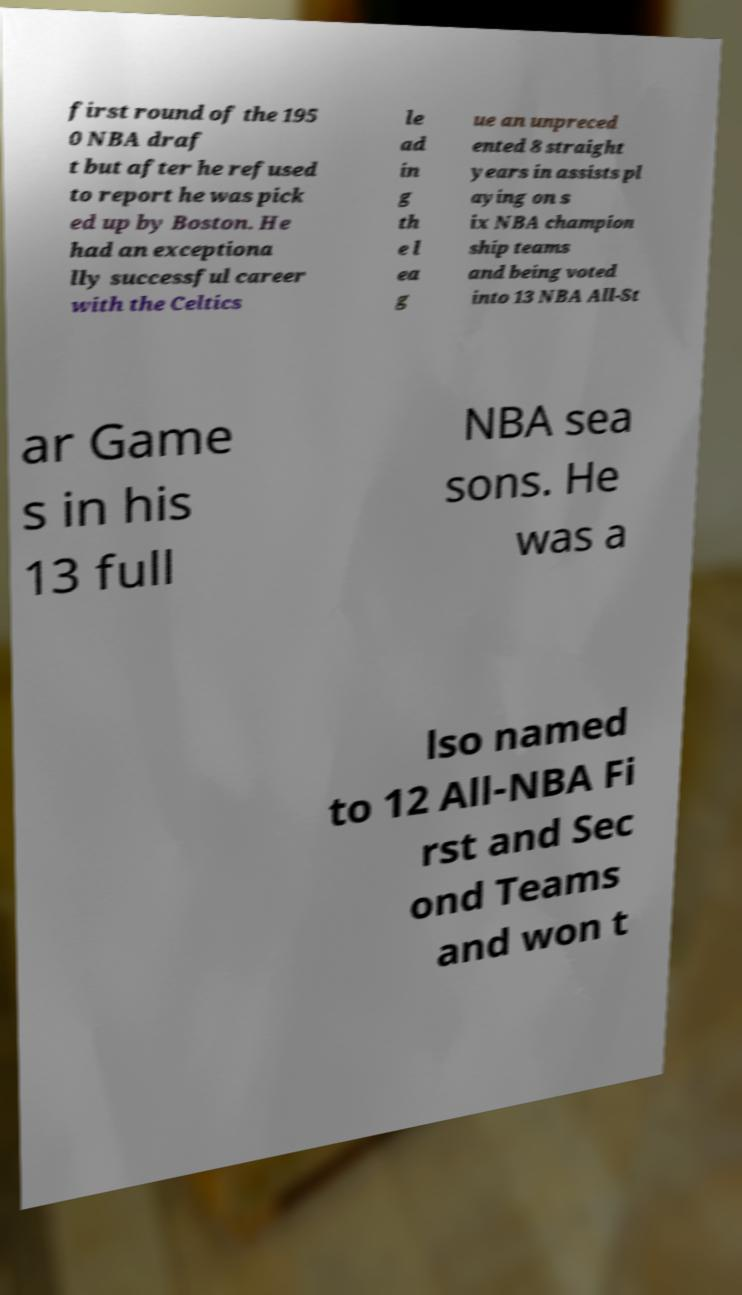Can you read and provide the text displayed in the image?This photo seems to have some interesting text. Can you extract and type it out for me? first round of the 195 0 NBA draf t but after he refused to report he was pick ed up by Boston. He had an exceptiona lly successful career with the Celtics le ad in g th e l ea g ue an unpreced ented 8 straight years in assists pl aying on s ix NBA champion ship teams and being voted into 13 NBA All-St ar Game s in his 13 full NBA sea sons. He was a lso named to 12 All-NBA Fi rst and Sec ond Teams and won t 